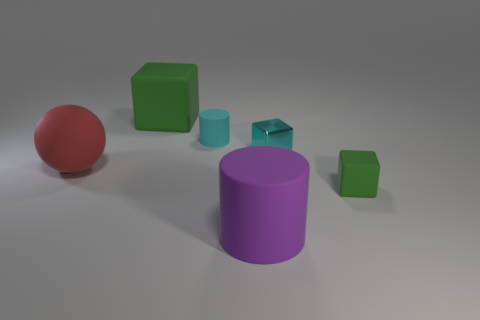Add 1 shiny cubes. How many objects exist? 7 Subtract all cylinders. How many objects are left? 4 Subtract 1 purple cylinders. How many objects are left? 5 Subtract all big spheres. Subtract all large red metal cubes. How many objects are left? 5 Add 6 metal things. How many metal things are left? 7 Add 2 large green cubes. How many large green cubes exist? 3 